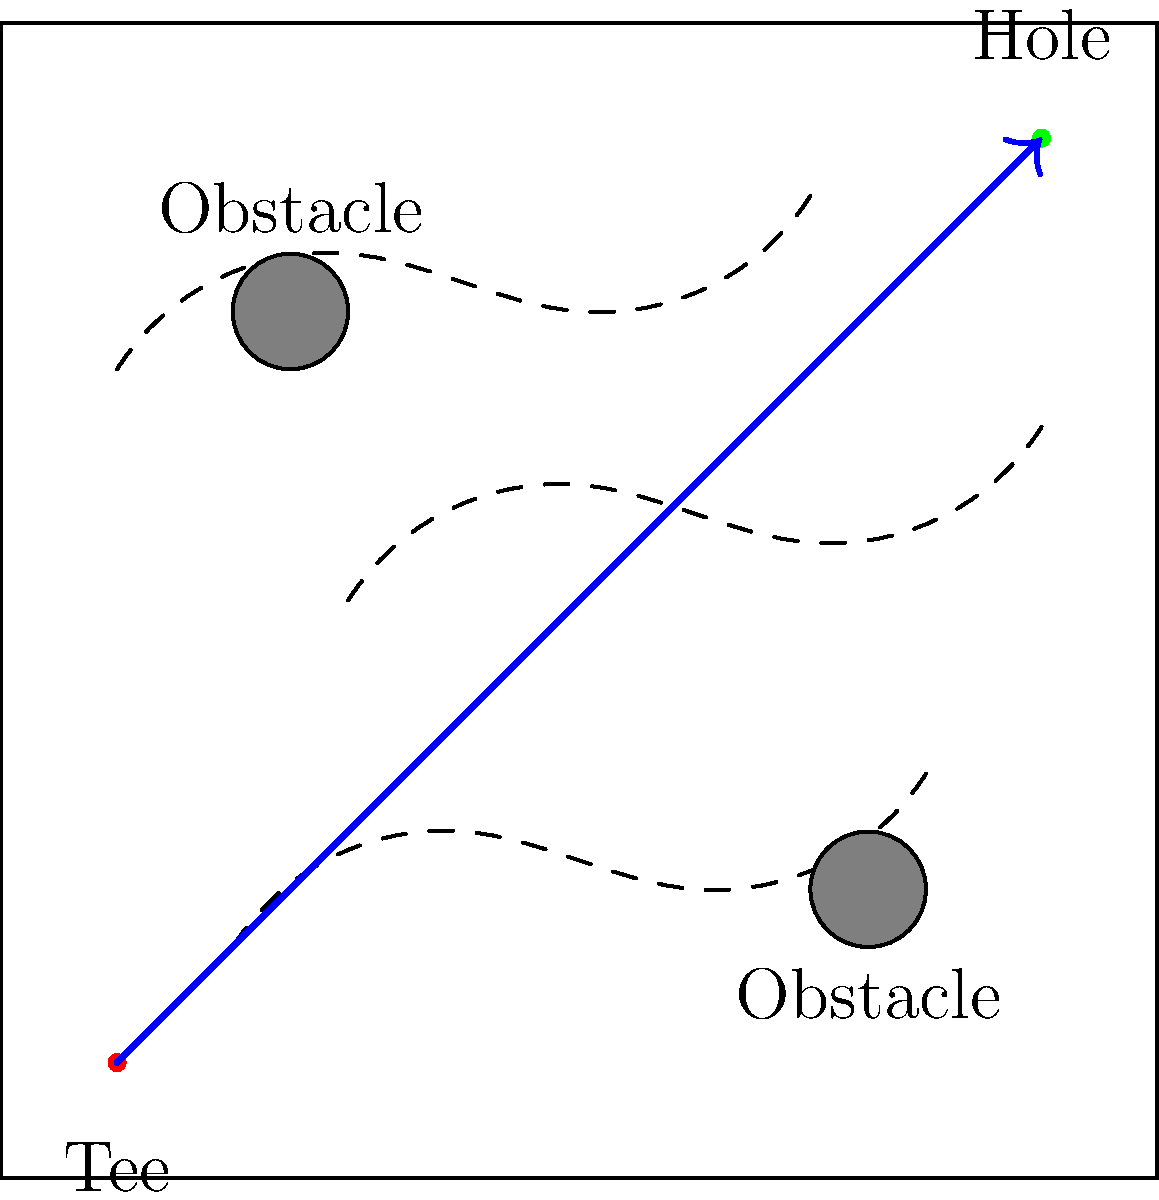Given the golf course layout shown in the diagram, which considers terrain contours (dashed lines) and obstacle placement (gray circles), what is the primary factor to consider when determining the optimal path (blue arrow) from tee to hole to minimize the number of strokes? To determine the optimal path for minimizing the number of strokes, we need to consider several factors:

1. Terrain contours: The dashed lines represent elevation changes on the course. Golf balls tend to roll downhill, so using the contours can help reduce the number of strokes needed.

2. Obstacles: The gray circles represent hazards or obstacles that should be avoided. Going around these obstacles is usually preferable to risking a penalty stroke.

3. Distance: While not always the most important factor, the overall distance of the path should be considered, as shorter paths generally require fewer strokes.

4. Shot difficulty: Some paths may require more difficult shots, which increase the risk of errors and additional strokes.

Considering these factors, the primary consideration for optimizing the path is the interplay between terrain and obstacles. The optimal path (blue arrow) in the diagram takes advantage of the terrain contours to guide the ball while avoiding the obstacles.

The path starts by using the downward slope of the first contour to gain distance, then curves to avoid the first obstacle. It then uses the upward slope of the second contour to gain height and clear the second obstacle, before using the final downward slope to approach the hole.

This path minimizes the impact of obstacles while maximizing the use of favorable terrain, which is the most crucial factor in reducing the number of strokes required to complete the hole.
Answer: Interplay between terrain and obstacles 